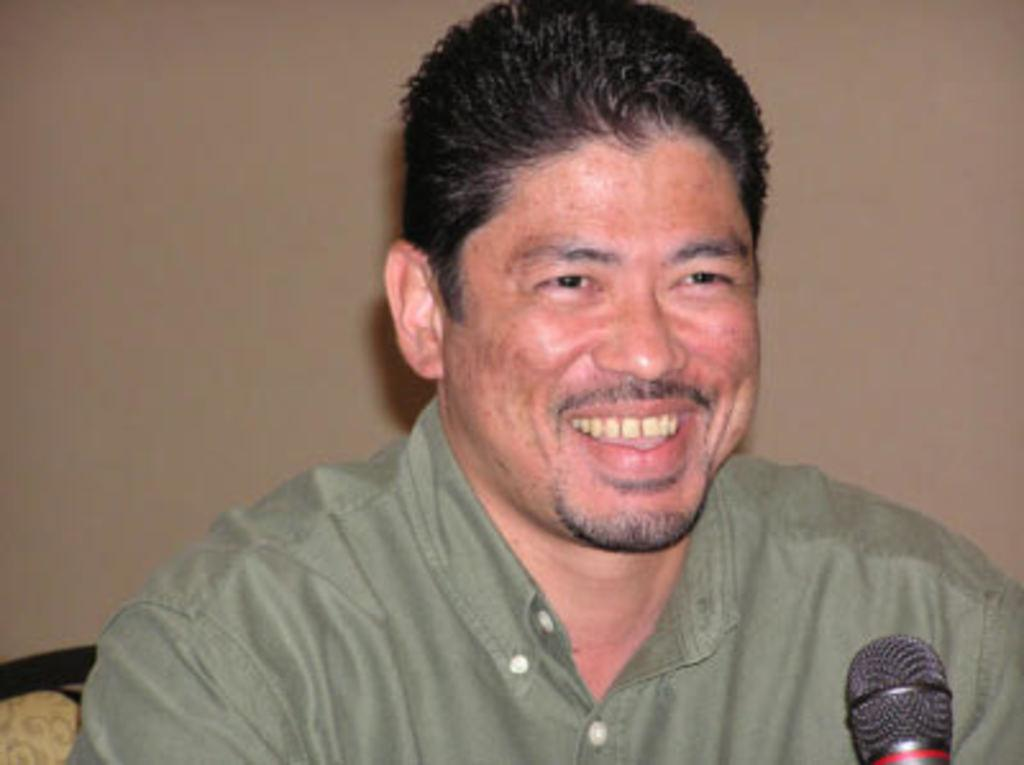Who or what is present in the image? There is a person in the image. What is the person doing or expressing? The person is smiling. What is the person wearing? The person is wearing a green dress. What object can be seen in the image besides the person? There is a microphone (mic) in the image. What color is the background of the image? The background of the image is brown. What type of collar is the person wearing in the image? The person is not wearing a collar in the image; they are wearing a green dress. How does the person expand their vocal range while using the microphone? The image does not show the person using the microphone or provide any information about their vocal range, so it cannot be determined from the image. 